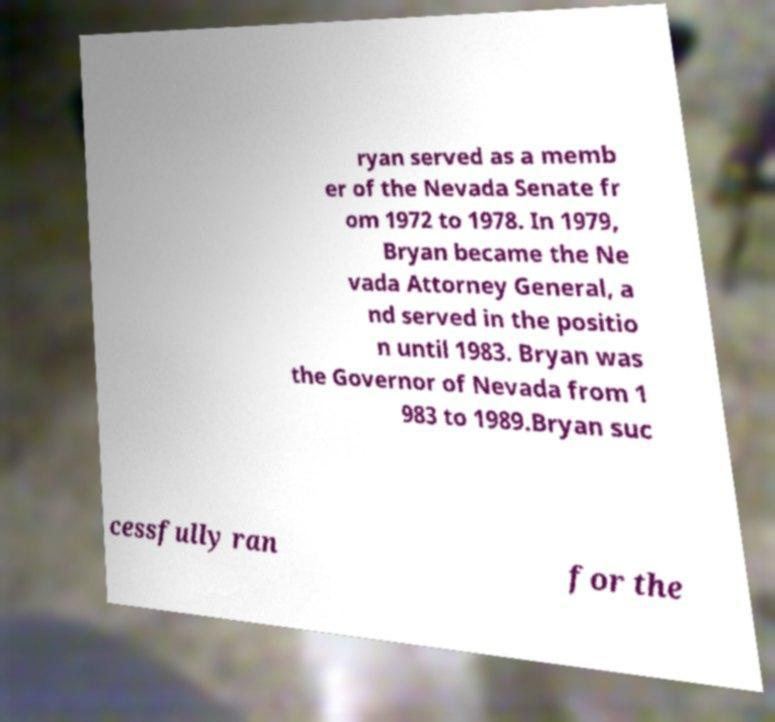Can you read and provide the text displayed in the image?This photo seems to have some interesting text. Can you extract and type it out for me? ryan served as a memb er of the Nevada Senate fr om 1972 to 1978. In 1979, Bryan became the Ne vada Attorney General, a nd served in the positio n until 1983. Bryan was the Governor of Nevada from 1 983 to 1989.Bryan suc cessfully ran for the 